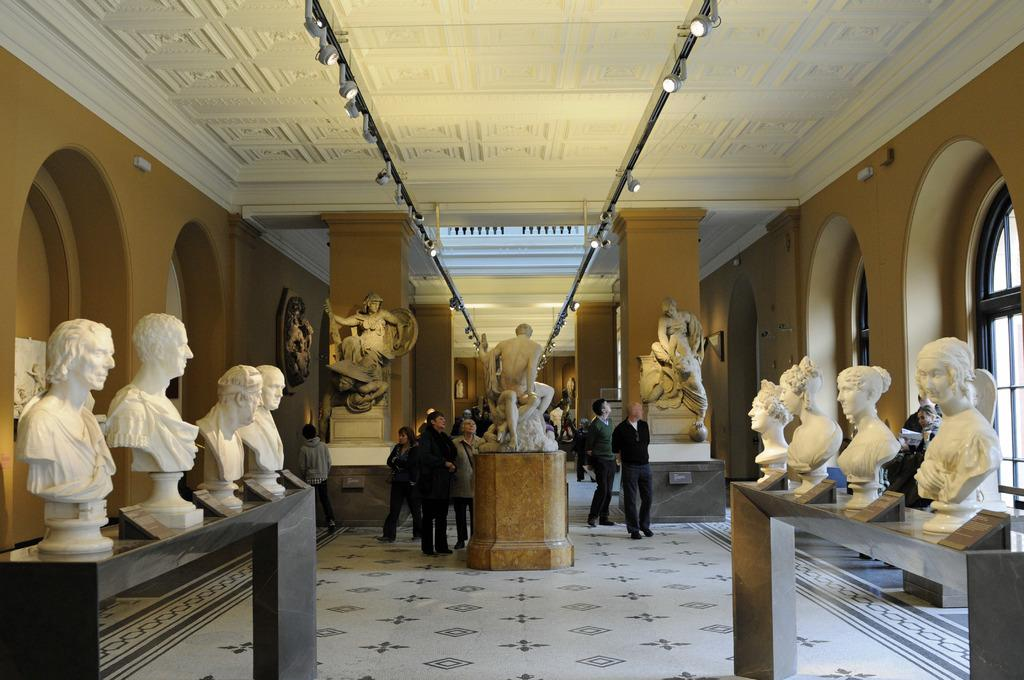What can be seen in the image that represents historical or artistic figures? There are statues in the image. What can be seen in the image that provides information about the location or people? There are name boards in the image. What can be seen in the image that allows light to enter the space? There are windows in the image. What can be seen in the image that provides illumination? There are lights in the image. What can be seen in the image that supports the structure? There are pillars in the image. What can be seen in the image that covers the top of the structure? There is a roof in the image. What can be seen in the image that represents a gathering of individuals? There is a group of people standing on the floor in the image. How many socks are visible on the statues in the image? There are no socks present in the image; it features statues, name boards, windows, lights, pillars, a roof, and a group of people standing on the floor. What type of breath can be seen coming from the group of people in the image? There is no visible breath in the image; it is a still image and does not depict any movement or action. 